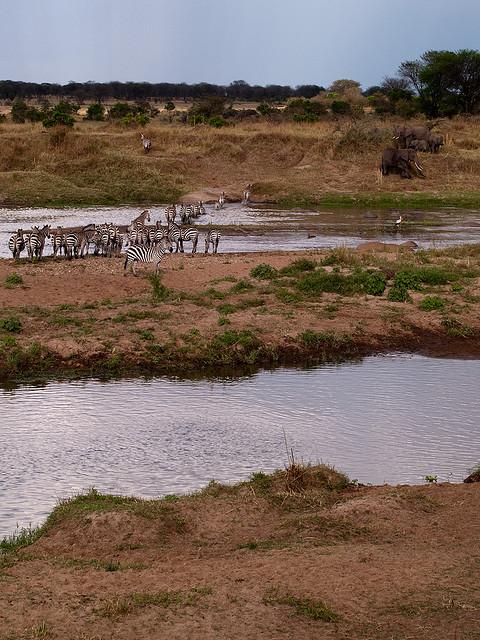What other animal, besides zebras, can be seen?
Keep it brief. Bird. How many types of animals are there?
Quick response, please. 2. Is this a large body of water?
Keep it brief. No. How can the Zebra get back to the mainland?
Quick response, please. Swim. Are these zebras in the wild?
Answer briefly. Yes. 